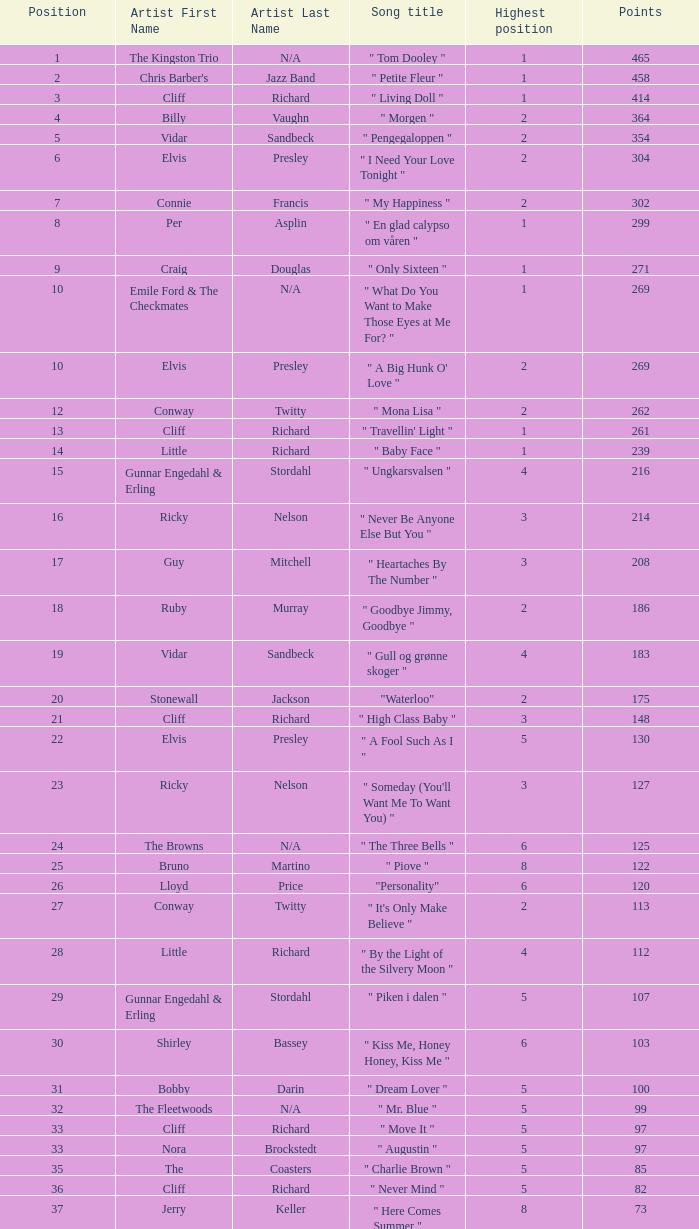What is the nme of the song performed by billy vaughn? " Morgen ". 